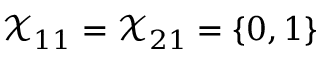<formula> <loc_0><loc_0><loc_500><loc_500>\mathcal { X } _ { 1 1 } = \mathcal { X } _ { 2 1 } = \{ 0 , 1 \}</formula> 